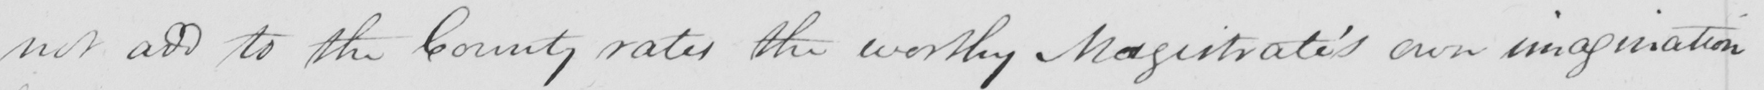Please provide the text content of this handwritten line. not add to the County rates the worthy Magistrate ' s own imagination 